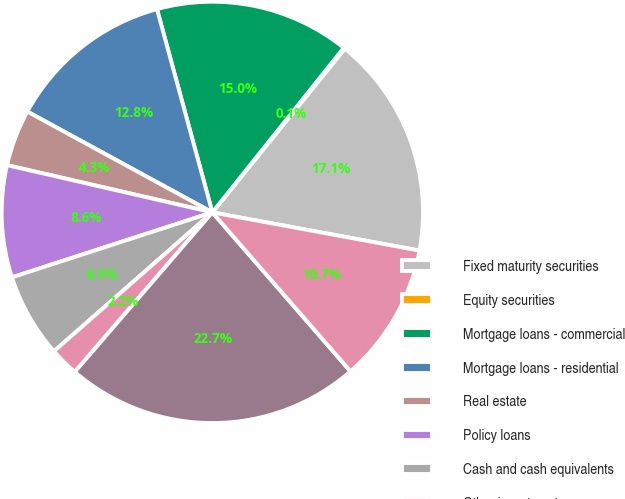<chart> <loc_0><loc_0><loc_500><loc_500><pie_chart><fcel>Fixed maturity securities<fcel>Equity securities<fcel>Mortgage loans - commercial<fcel>Mortgage loans - residential<fcel>Real estate<fcel>Policy loans<fcel>Cash and cash equivalents<fcel>Other investments<fcel>Total before investment<fcel>Investment expenses<nl><fcel>17.08%<fcel>0.1%<fcel>14.96%<fcel>12.83%<fcel>4.34%<fcel>8.59%<fcel>6.47%<fcel>2.22%<fcel>22.71%<fcel>10.71%<nl></chart> 